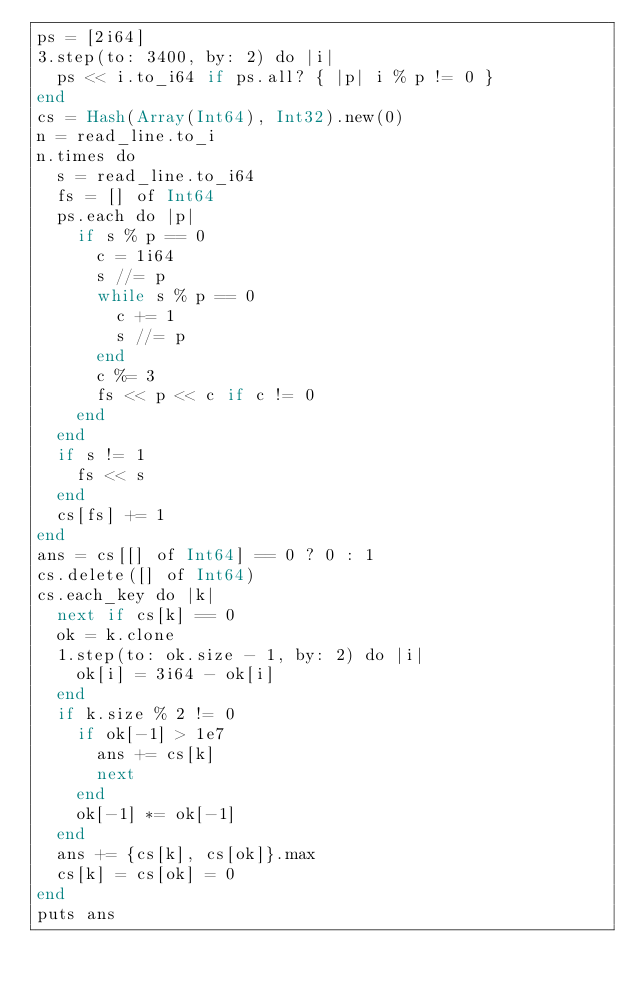<code> <loc_0><loc_0><loc_500><loc_500><_Crystal_>ps = [2i64]
3.step(to: 3400, by: 2) do |i|
  ps << i.to_i64 if ps.all? { |p| i % p != 0 }
end
cs = Hash(Array(Int64), Int32).new(0)
n = read_line.to_i
n.times do
  s = read_line.to_i64
  fs = [] of Int64
  ps.each do |p|
    if s % p == 0
      c = 1i64
      s //= p
      while s % p == 0
        c += 1
        s //= p
      end
      c %= 3
      fs << p << c if c != 0
    end
  end
  if s != 1
    fs << s
  end
  cs[fs] += 1
end
ans = cs[[] of Int64] == 0 ? 0 : 1
cs.delete([] of Int64)
cs.each_key do |k|
  next if cs[k] == 0
  ok = k.clone
  1.step(to: ok.size - 1, by: 2) do |i|
    ok[i] = 3i64 - ok[i]
  end
  if k.size % 2 != 0
    if ok[-1] > 1e7
      ans += cs[k]
      next
    end
    ok[-1] *= ok[-1]
  end
  ans += {cs[k], cs[ok]}.max
  cs[k] = cs[ok] = 0
end
puts ans
</code> 